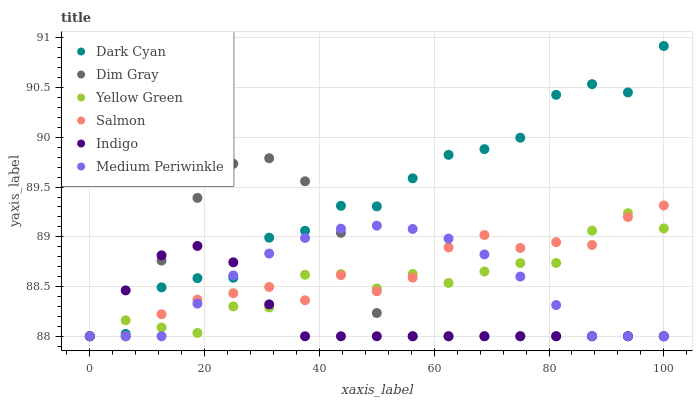Does Indigo have the minimum area under the curve?
Answer yes or no. Yes. Does Dark Cyan have the maximum area under the curve?
Answer yes or no. Yes. Does Yellow Green have the minimum area under the curve?
Answer yes or no. No. Does Yellow Green have the maximum area under the curve?
Answer yes or no. No. Is Medium Periwinkle the smoothest?
Answer yes or no. Yes. Is Dark Cyan the roughest?
Answer yes or no. Yes. Is Indigo the smoothest?
Answer yes or no. No. Is Indigo the roughest?
Answer yes or no. No. Does Dim Gray have the lowest value?
Answer yes or no. Yes. Does Dark Cyan have the highest value?
Answer yes or no. Yes. Does Yellow Green have the highest value?
Answer yes or no. No. Does Dark Cyan intersect Dim Gray?
Answer yes or no. Yes. Is Dark Cyan less than Dim Gray?
Answer yes or no. No. Is Dark Cyan greater than Dim Gray?
Answer yes or no. No. 